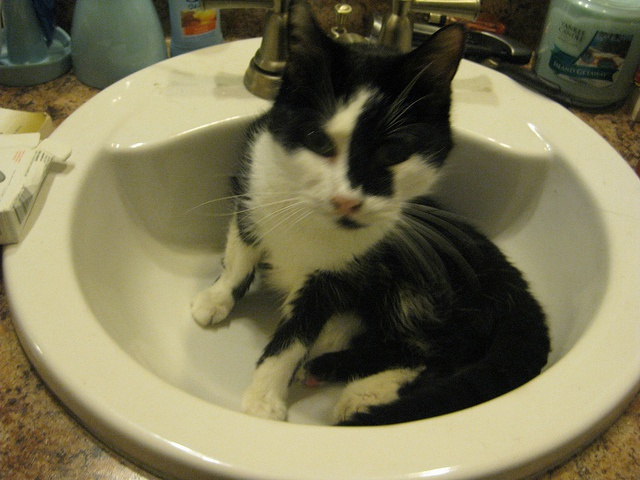Describe the objects in this image and their specific colors. I can see sink in khaki, brown, black, tan, and olive tones and cat in brown, black, olive, and gray tones in this image. 